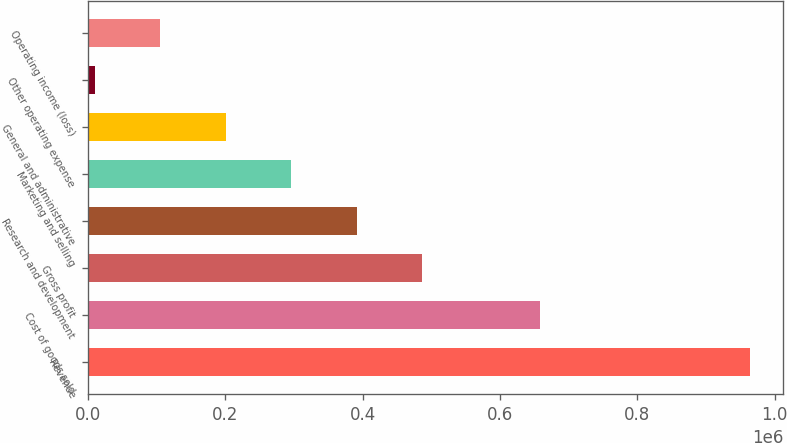Convert chart. <chart><loc_0><loc_0><loc_500><loc_500><bar_chart><fcel>Revenue<fcel>Cost of goods sold<fcel>Gross profit<fcel>Research and development<fcel>Marketing and selling<fcel>General and administrative<fcel>Other operating expense<fcel>Operating income (loss)<nl><fcel>964147<fcel>658332<fcel>486966<fcel>391530<fcel>296094<fcel>200658<fcel>9786<fcel>105222<nl></chart> 